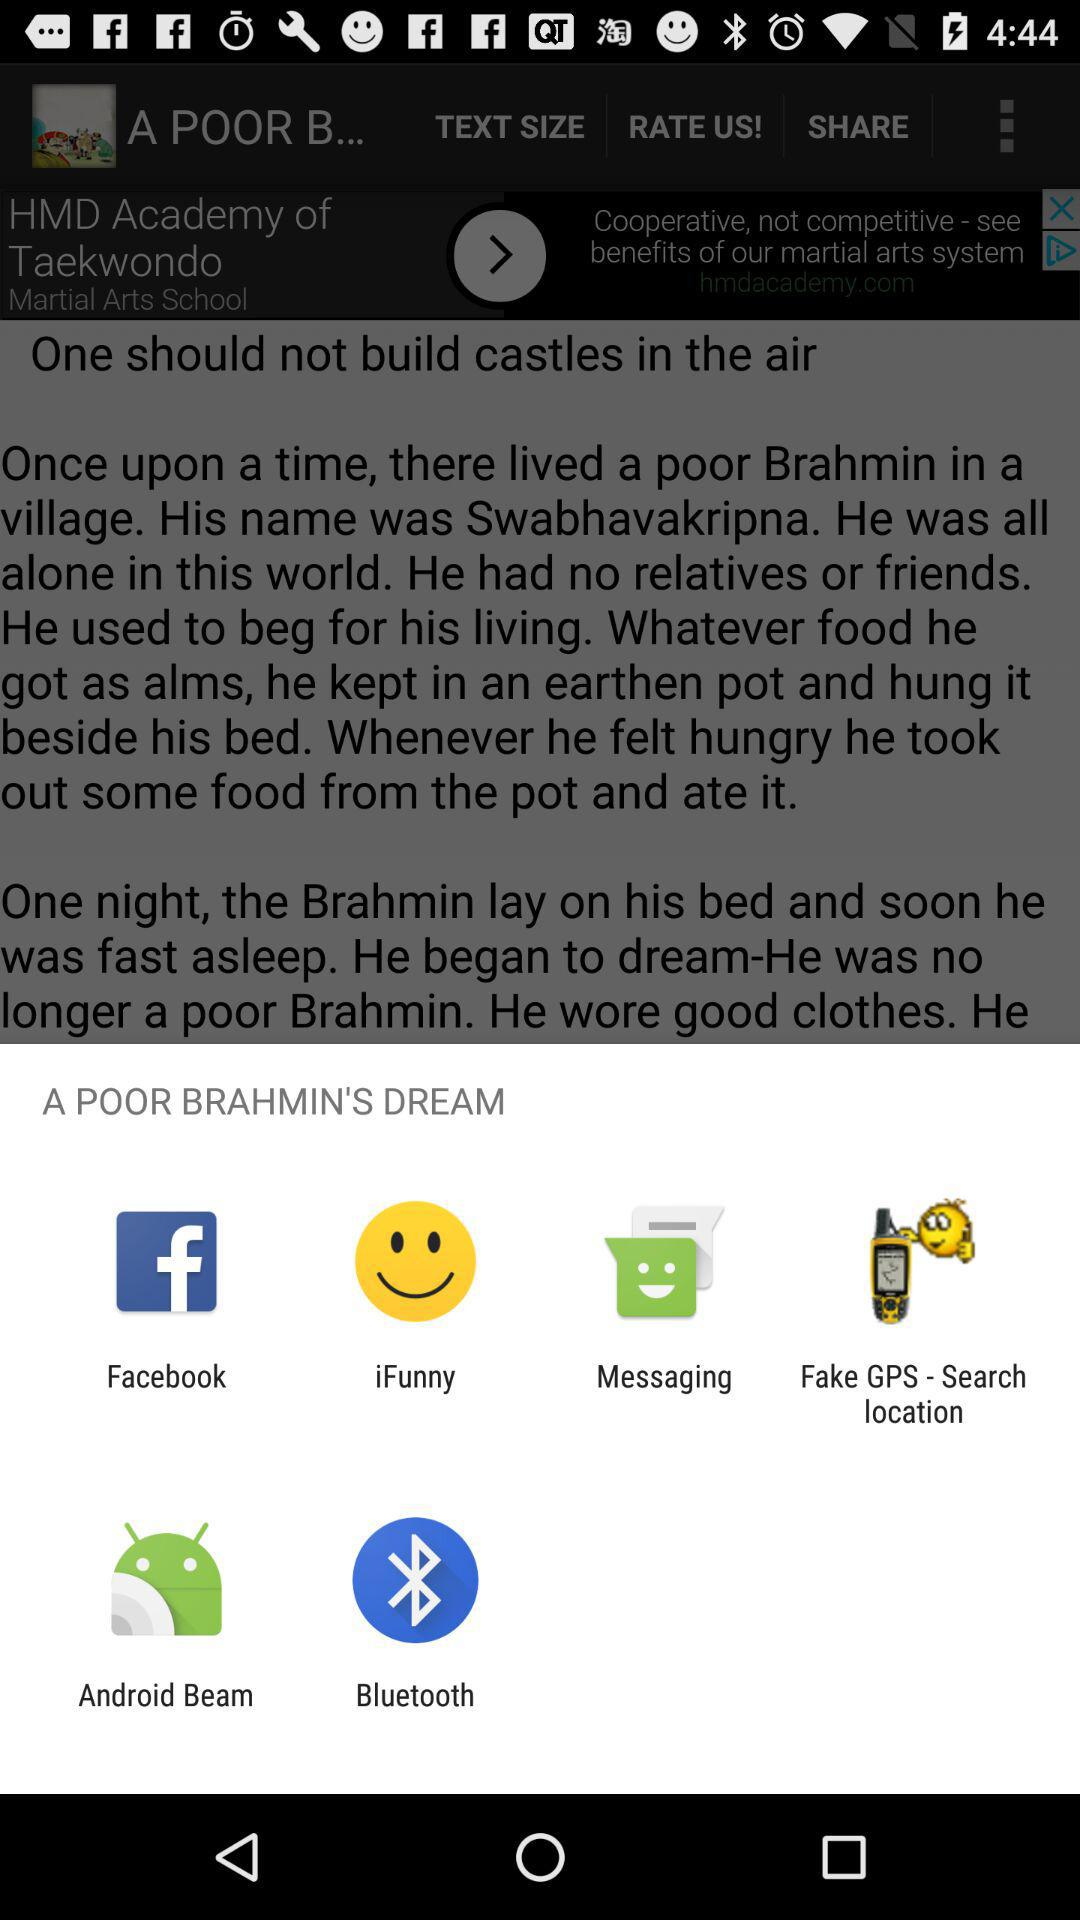Which application can I use to share? You can use "Facebook", "iFunny", "Messaging", "Fake GPS - Search location", "Android Beam" and "Bluetooth" to share. 